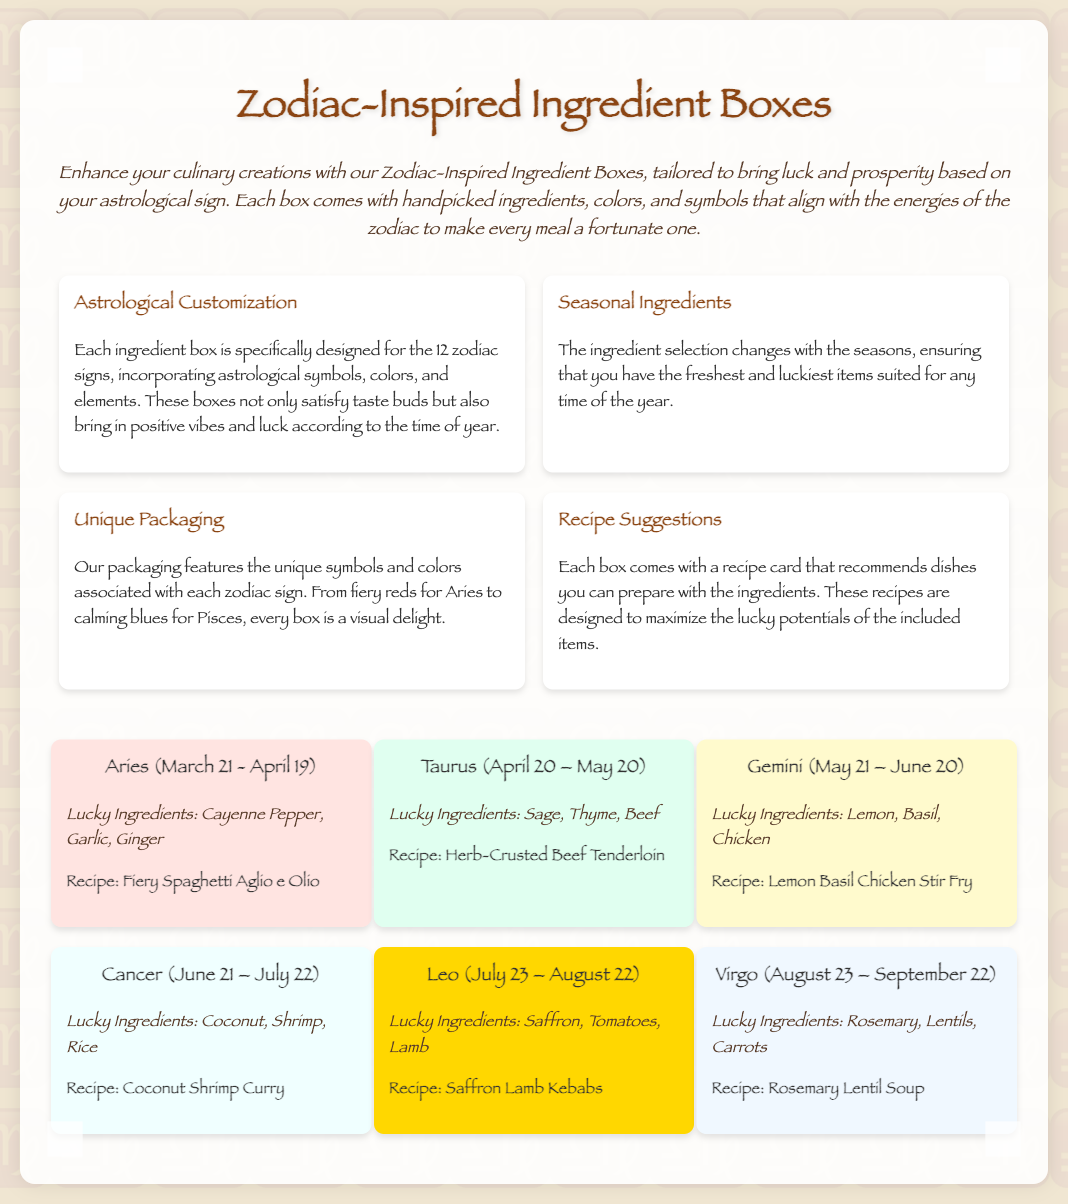What is the title of the document? The title, found at the top of the document, indicates the main subject it addresses.
Answer: Zodiac-Inspired Ingredient Boxes What are the lucky ingredients for Aries? This information can be found in the section describing the ingredients for each zodiac sign.
Answer: Cayenne Pepper, Garlic, Ginger How many zodiac signs are featured in the document? The document provides information about ingredient boxes specifically designed for the astrological zodiac signs.
Answer: 12 What is the recipe suggestion for Cancer? The recipe suggestion is part of the information provided for each zodiac sign's ingredients.
Answer: Coconut Shrimp Curry Which color represents Leo in the document? The background color of Leo's section indicates the associated color for this zodiac sign.
Answer: #FFD700 What is the purpose of the Zodiac-Inspired Ingredient Boxes? The purpose is summarized in the product description, which outlines the main benefits of the boxes.
Answer: Bring luck and prosperity What type of customization is mentioned for the ingredient boxes? This detail relates to how each box is tailored according to astrology.
Answer: Astrological Customization Which sign is associated with the recipe "Lemon Basil Chicken Stir Fry"? This requires recognizing the connection between recipes and zodiac signs in the document.
Answer: Gemini 